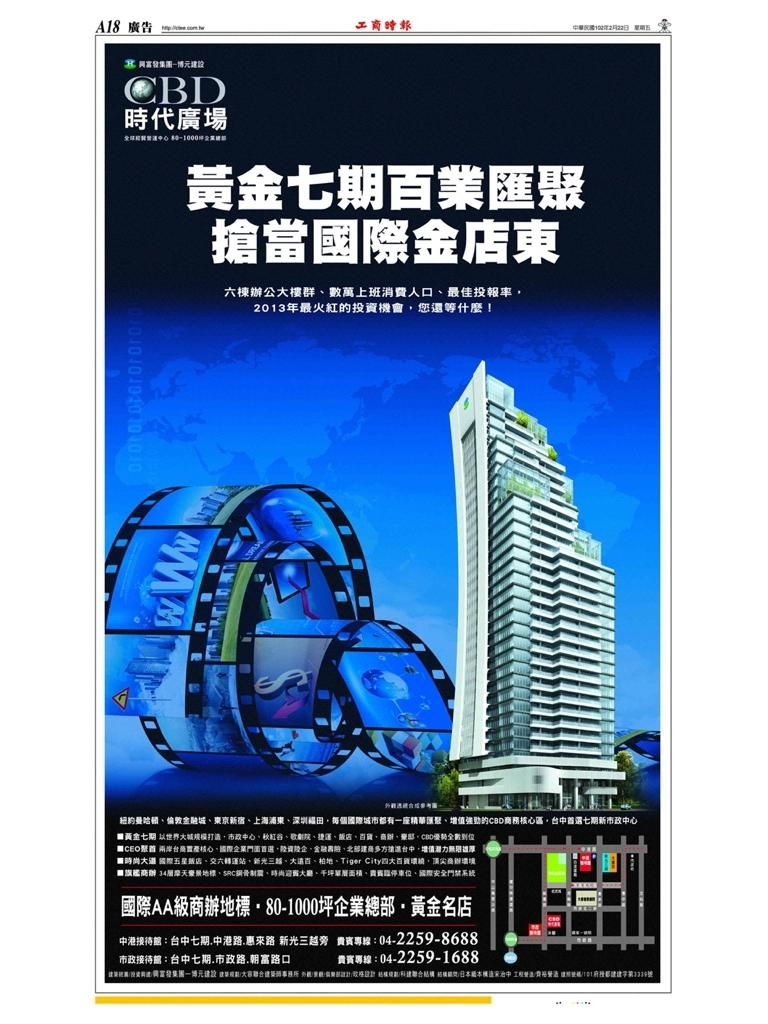<image>
Describe the image concisely. Poster of a buliding with chinese words and the number 22598688. 